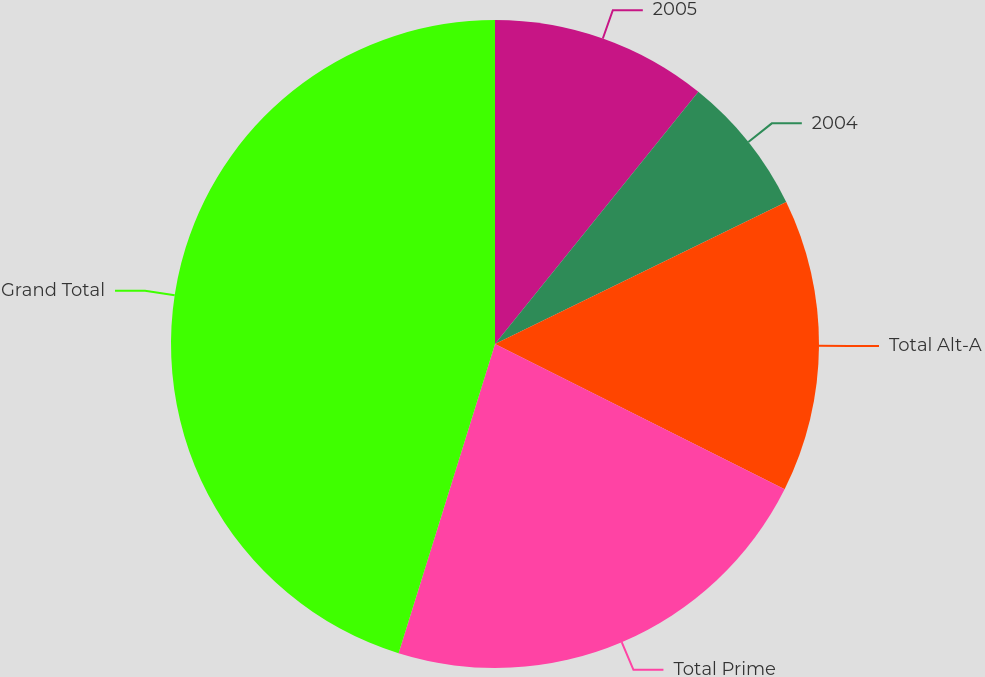Convert chart. <chart><loc_0><loc_0><loc_500><loc_500><pie_chart><fcel>2005<fcel>2004<fcel>Total Alt-A<fcel>Total Prime<fcel>Grand Total<nl><fcel>10.8%<fcel>6.98%<fcel>14.62%<fcel>22.41%<fcel>45.19%<nl></chart> 